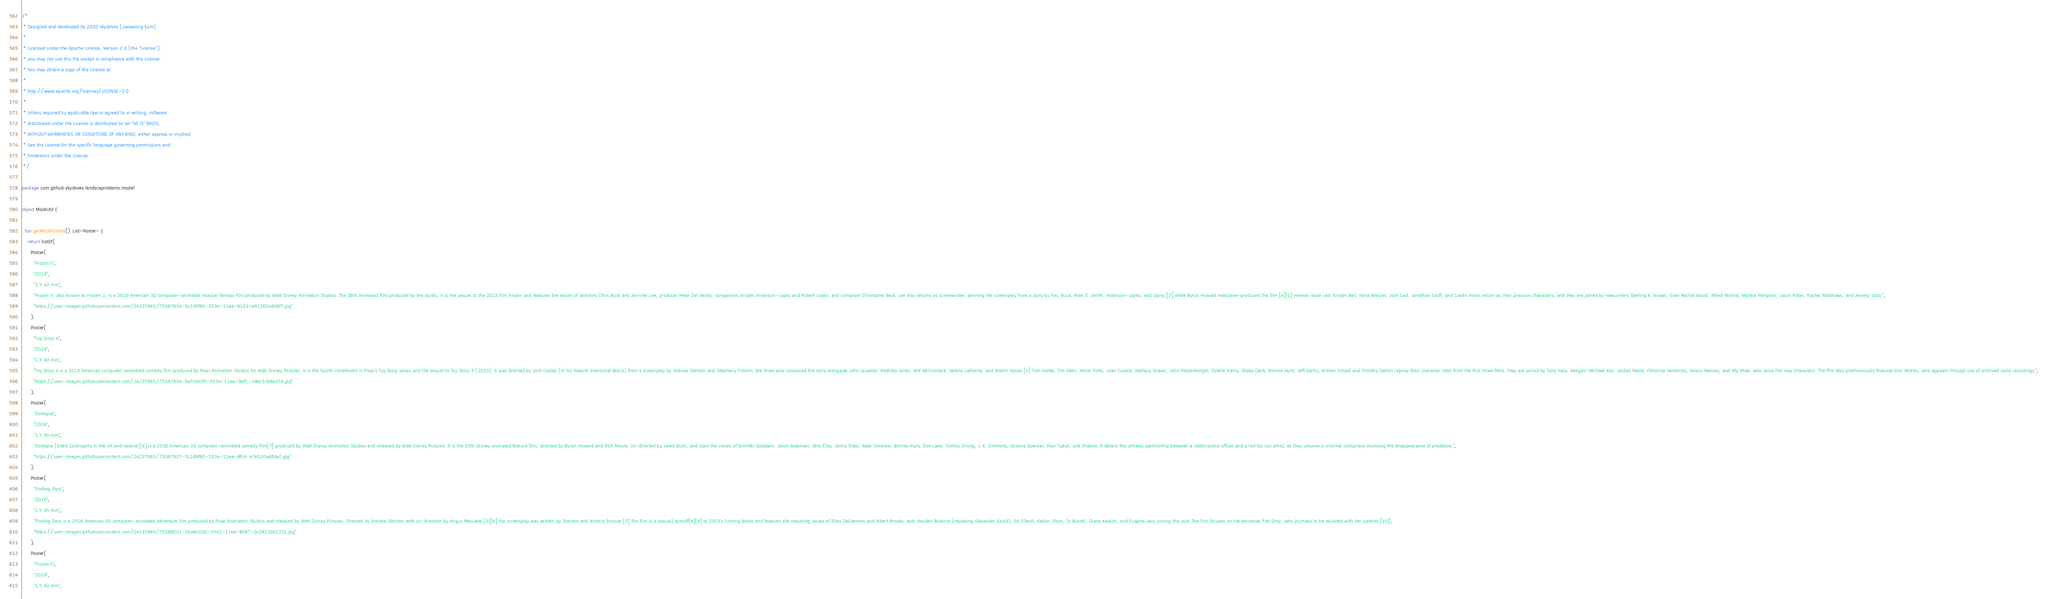Convert code to text. <code><loc_0><loc_0><loc_500><loc_500><_Kotlin_>/*
 * Designed and developed by 2020 skydoves (Jaewoong Eum)
 *
 * Licensed under the Apache License, Version 2.0 (the "License");
 * you may not use this file except in compliance with the License.
 * You may obtain a copy of the License at
 *
 * http://www.apache.org/licenses/LICENSE-2.0
 *
 * Unless required by applicable law or agreed to in writing, software
 * distributed under the License is distributed on an "AS IS" BASIS,
 * WITHOUT WARRANTIES OR CONDITIONS OF ANY KIND, either express or implied.
 * See the License for the specific language governing permissions and
 * limitations under the License.
 */

package com.github.skydoves.landscapistdemo.model

object MockUtil {

  fun getMockPosters(): List<Poster> {
    return listOf(
      Poster(
        "Frozen II",
        "2019",
        "1 h 43 min",
        "Frozen II, also known as Frozen 2, is a 2019 American 3D computer-animated musical fantasy film produced by Walt Disney Animation Studios. The 58th animated film produced by the studio, it is the sequel to the 2013 film Frozen and features the return of directors Chris Buck and Jennifer Lee, producer Peter Del Vecho, songwriters Kristen Anderson-Lopez and Robert Lopez, and composer Christophe Beck. Lee also returns as screenwriter, penning the screenplay from a story by her, Buck, Marc E. Smith, Anderson-Lopez, and Lopez,[2] while Byron Howard executive-produced the film.[a][1] Veteran voice cast Kristen Bell, Idina Menzel, Josh Gad, Jonathan Groff, and Ciarán Hinds return as their previous characters, and they are joined by newcomers Sterling K. Brown, Evan Rachel Wood, Alfred Molina, Martha Plimpton, Jason Ritter, Rachel Matthews, and Jeremy Sisto.",
        "https://user-images.githubusercontent.com/24237865/75087936-5c1d9f80-553e-11ea-81d3-a912634dd8f7.jpg"
      ),
      Poster(
        "Toy Story 4",
        "2019",
        "1 h 40 min",
        "Toy Story 4 is a 2019 American computer-animated comedy film produced by Pixar Animation Studios for Walt Disney Pictures. It is the fourth installment in Pixar's Toy Story series and the sequel to Toy Story 3 (2010). It was directed by Josh Cooley (in his feature directorial debut) from a screenplay by Andrew Stanton and Stephany Folsom; the three also conceived the story alongside John Lasseter, Rashida Jones, Will McCormack, Valerie LaPointe, and Martin Hynes.[2] Tom Hanks, Tim Allen, Annie Potts, Joan Cusack, Wallace Shawn, John Ratzenberger, Estelle Harris, Blake Clark, Bonnie Hunt, Jeff Garlin, Kristen Schaal and Timothy Dalton reprise their character roles from the first three films. They are joined by Tony Hale, Keegan-Michael Key, Jordan Peele, Christina Hendricks, Keanu Reeves, and Ally Maki, who voice the new characters. The film also posthumously features Don Rickles, who appears through use of archived voice recordings.",
        "https://user-images.githubusercontent.com/24237865/75087934-5a53dc00-553e-11ea-94f1-494c1c68a574.jpg"
      ),
      Poster(
        "Zootopia",
        "2016",
        "1 h 50 min",
        "Zootopia (titled Zootropolis in the UK and Ireland)[6] is a 2016 American 3D computer-animated comedy film[7] produced by Walt Disney Animation Studios and released by Walt Disney Pictures. It is the 55th Disney animated feature film, directed by Byron Howard and Rich Moore, co-directed by Jared Bush, and stars the voices of Ginnifer Goodwin, Jason Bateman, Idris Elba, Jenny Slate, Nate Torrence, Bonnie Hunt, Don Lake, Tommy Chong, J. K. Simmons, Octavia Spencer, Alan Tudyk, and Shakira. It details the unlikely partnership between a rabbit police officer and a red fox con artist, as they uncover a criminal conspiracy involving the disappearance of predators.",
        "https://user-images.githubusercontent.com/24237865/75087937-5c1d9f80-553e-11ea-8fc9-a7e520addde0.jpg"
      ),
      Poster(
        "Finding Dory",
        "2016",
        "1 h 45 min",
        "Finding Dory is a 2016 American 3D computer-animated adventure film produced by Pixar Animation Studios and released by Walt Disney Pictures. Directed by Andrew Stanton with co-direction by Angus MacLane,[5][6] the screenplay was written by Stanton and Victoria Strouse.[7] The film is a sequel/spinoff[8][9] to 2003's Finding Nemo and features the returning voices of Ellen DeGeneres and Albert Brooks, with Hayden Rolence (replacing Alexander Gould), Ed O'Neill, Kaitlin Olson, Ty Burrell, Diane Keaton, and Eugene Levy joining the cast. The film focuses on the amnesiac fish Dory, who journeys to be reunited with her parents.[10]",
        "https://user-images.githubusercontent.com/24237865/75088201-0ba84100-5542-11ea-8587-0c2823b05351.jpg"
      ),
      Poster(
        "Frozen II",
        "2019",
        "1 h 43 min",</code> 